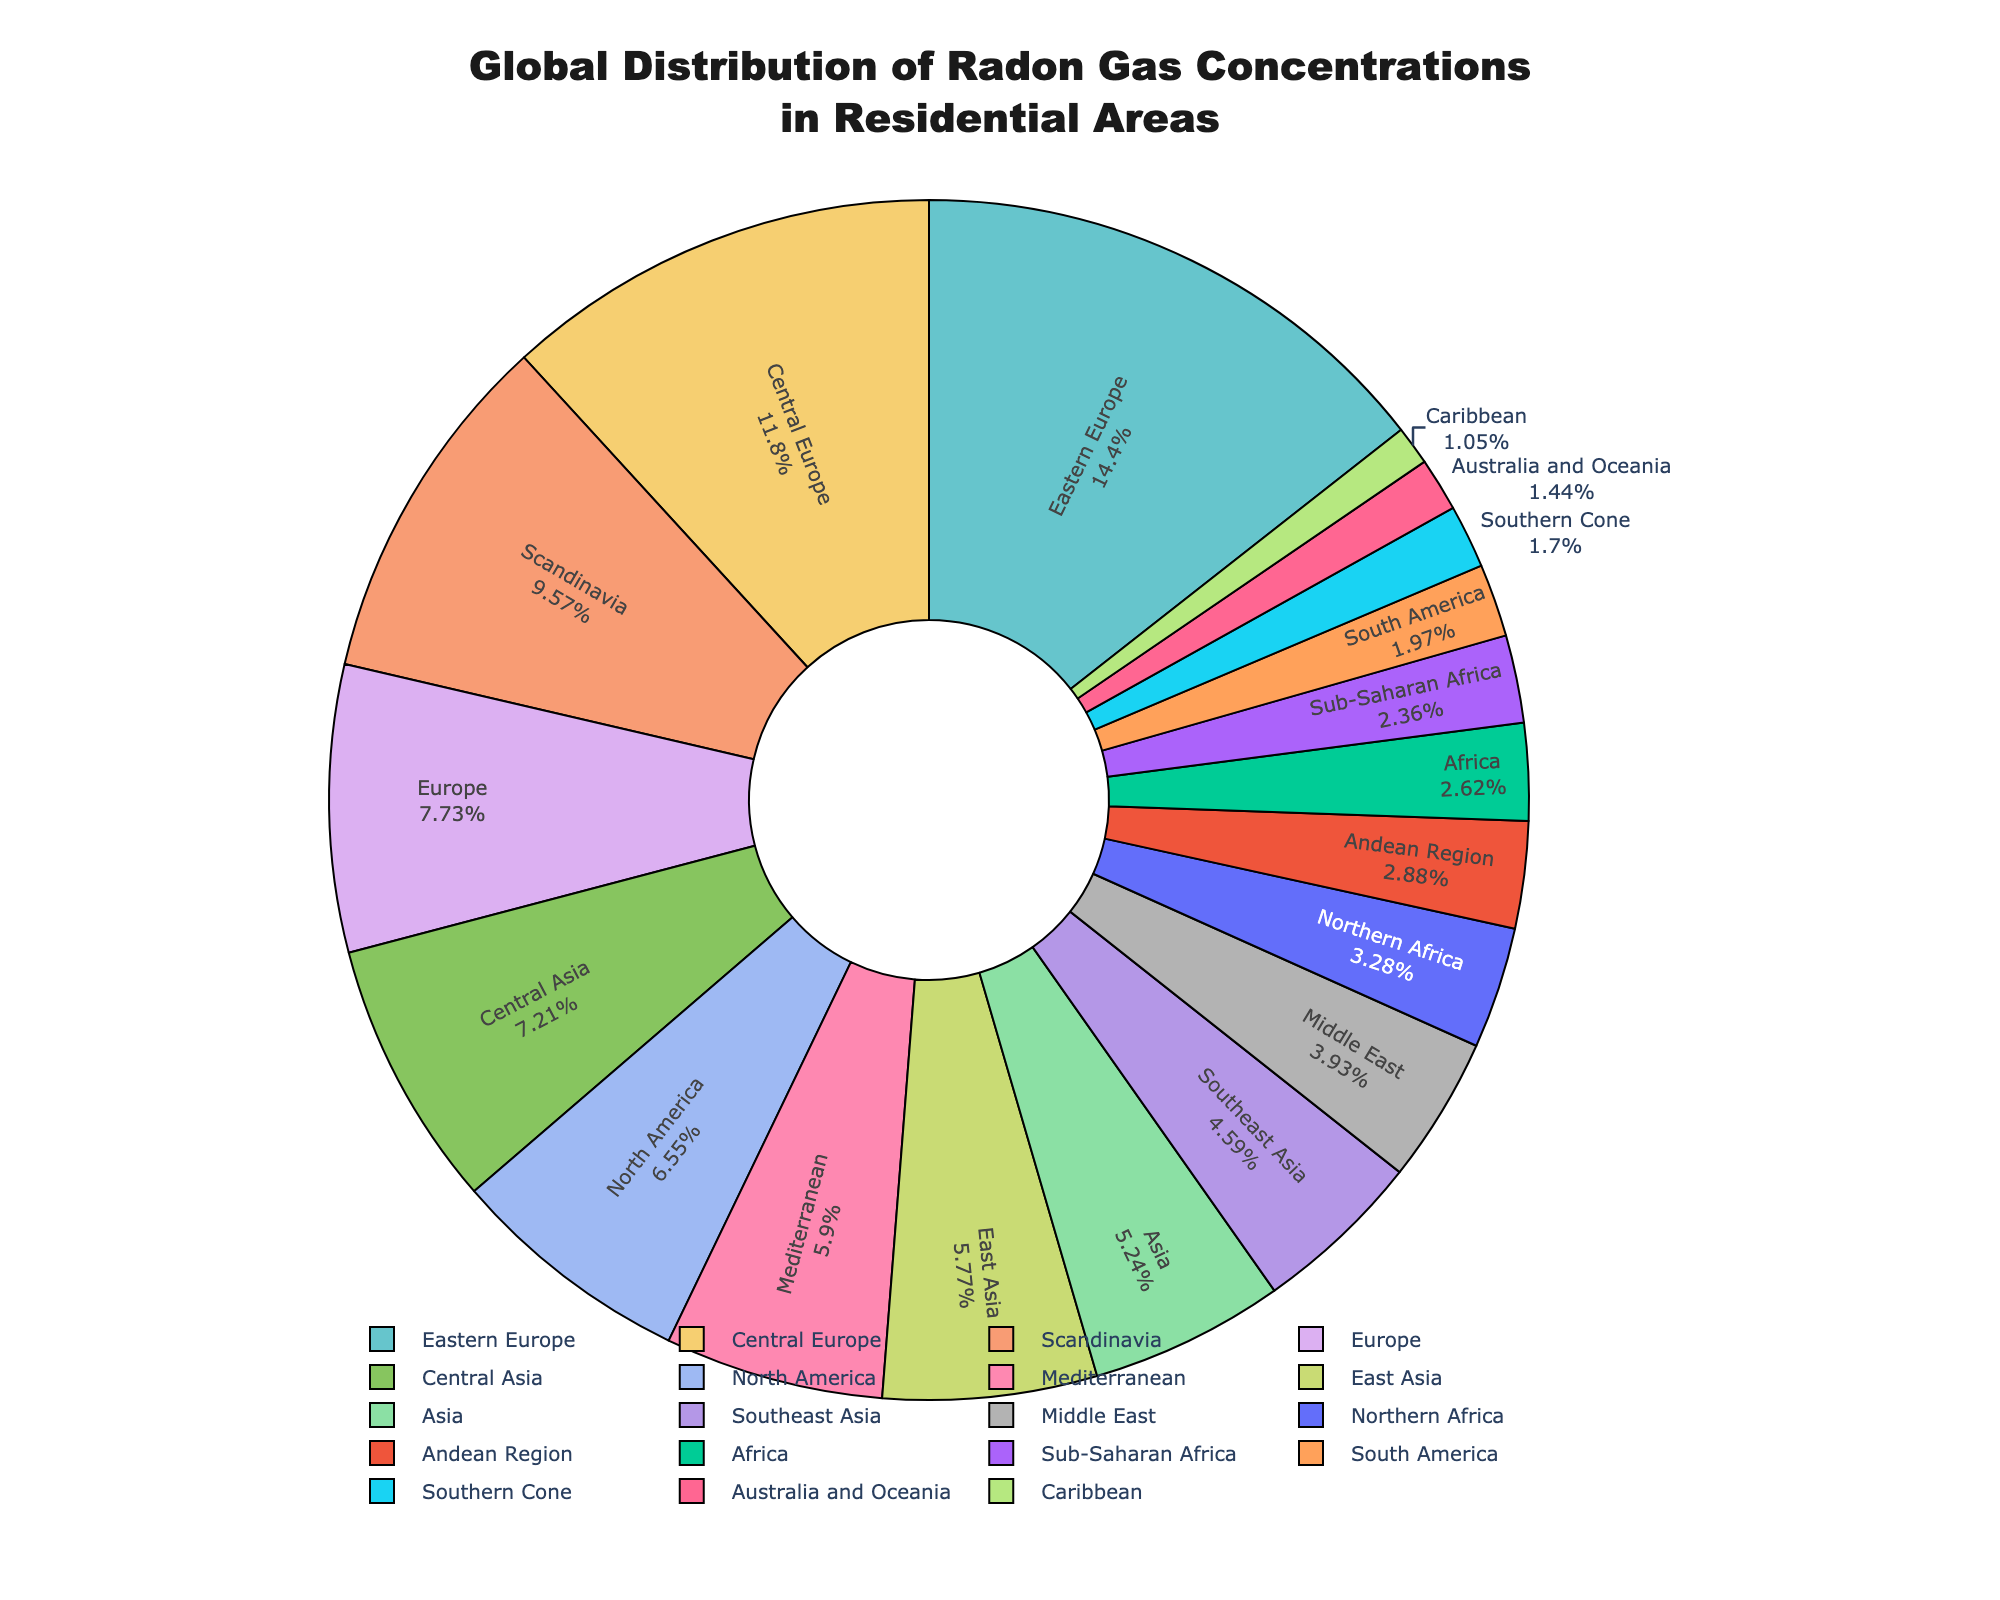Which region has the highest average radon concentration? By inspecting the pie chart, we can see that Eastern Europe has the largest segment, indicating it has the highest average radon concentration among all the regions displayed.
Answer: Eastern Europe Which region has the lowest average radon concentration? The pie chart indicates that the Caribbean has the smallest segment, representing the lowest average radon concentration compared to other regions.
Answer: Caribbean Which regions have an average radon concentration greater than 50 Bq/m³? From the pie chart, we can identify that Eastern Europe, Central Europe, Scandinavia, Europe, and North America have segments that represent average radon concentrations more than 50 Bq/m³.
Answer: Eastern Europe, Central Europe, Scandinavia, Europe, North America What is the difference between the average radon concentration in Scandinavia and Northern Africa? Scandinavia has an average radon concentration of 73 Bq/m³, and Northern Africa has 25 Bq/m³. Subtracting these: 73 - 25 gives the difference.
Answer: 48 Bq/m³ Which regions account for approximately 10% or more of the global radon concentration in residential areas? Observing the pie chart, the segments for Eastern Europe, Central Europe, and Scandinavia are each approximately 10% or more of the total, as indicated by their substantial relative sizes.
Answer: Eastern Europe, Central Europe, Scandinavia How does the radon concentration in Southern Cone compare to that in Australia and Oceania? The pie chart shows that Australia and Oceania have a radon concentration of 11 Bq/m³, while Southern Cone has 13 Bq/m³. Thus, Southern Cone's radon concentration is slightly higher.
Answer: Southern Cone is higher What is the average radon concentration of the regions with the highest and lowest concentrations combined? The highest average concentration is in Eastern Europe (110 Bq/m³) and the lowest is in the Caribbean (8 Bq/m³). Adding these and dividing by 2: (110 + 8) / 2 gives the average.
Answer: 59 Bq/m³ Which continents, as entire entities, can potentially have the regions with radon concentrations above 40 Bq/m³? Looking at the pie chart, Europe (including Central Europe, Eastern Europe, Scandinavia, and other parts of Europe) and North America show segments indicating more than 40 Bq/m³ radon concentrations.
Answer: Europe, North America 